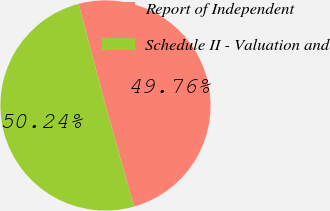Convert chart to OTSL. <chart><loc_0><loc_0><loc_500><loc_500><pie_chart><fcel>Report of Independent<fcel>Schedule II - Valuation and<nl><fcel>49.76%<fcel>50.24%<nl></chart> 